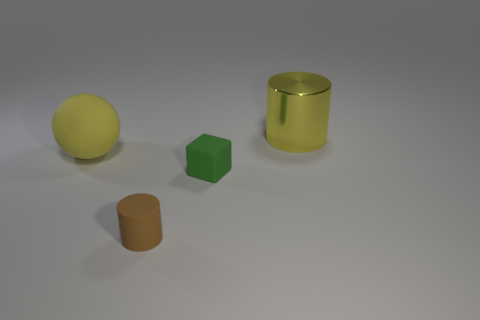Subtract all yellow blocks. Subtract all blue cylinders. How many blocks are left? 1 Subtract all red cylinders. How many red cubes are left? 0 Add 3 large things. How many small browns exist? 0 Subtract all large objects. Subtract all large yellow things. How many objects are left? 0 Add 2 rubber spheres. How many rubber spheres are left? 3 Add 3 large gray objects. How many large gray objects exist? 3 Add 2 tiny objects. How many objects exist? 6 Subtract all brown cylinders. How many cylinders are left? 1 Subtract 0 purple cylinders. How many objects are left? 4 Subtract all blocks. How many objects are left? 3 